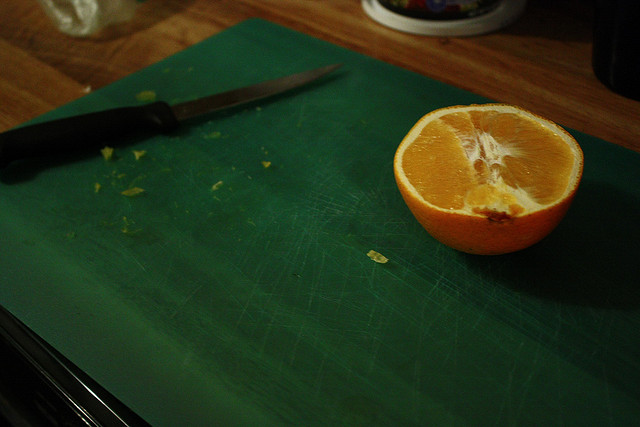How do you use a Navel orange in cooking or food preparation? Navel oranges are versatile in culinary uses. They can be eaten fresh, added to salads, used in marinades, or juiced for drinks and sauces due to their sweet flavor and substantial juice content. 